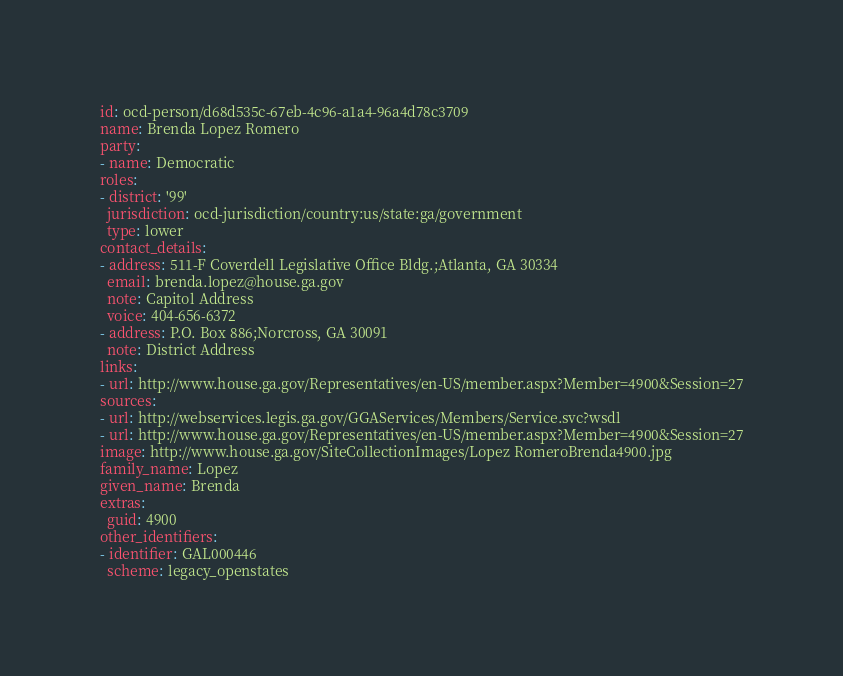Convert code to text. <code><loc_0><loc_0><loc_500><loc_500><_YAML_>id: ocd-person/d68d535c-67eb-4c96-a1a4-96a4d78c3709
name: Brenda Lopez Romero
party:
- name: Democratic
roles:
- district: '99'
  jurisdiction: ocd-jurisdiction/country:us/state:ga/government
  type: lower
contact_details:
- address: 511-F Coverdell Legislative Office Bldg.;Atlanta, GA 30334
  email: brenda.lopez@house.ga.gov
  note: Capitol Address
  voice: 404-656-6372
- address: P.O. Box 886;Norcross, GA 30091
  note: District Address
links:
- url: http://www.house.ga.gov/Representatives/en-US/member.aspx?Member=4900&Session=27
sources:
- url: http://webservices.legis.ga.gov/GGAServices/Members/Service.svc?wsdl
- url: http://www.house.ga.gov/Representatives/en-US/member.aspx?Member=4900&Session=27
image: http://www.house.ga.gov/SiteCollectionImages/Lopez RomeroBrenda4900.jpg
family_name: Lopez
given_name: Brenda
extras:
  guid: 4900
other_identifiers:
- identifier: GAL000446
  scheme: legacy_openstates
</code> 